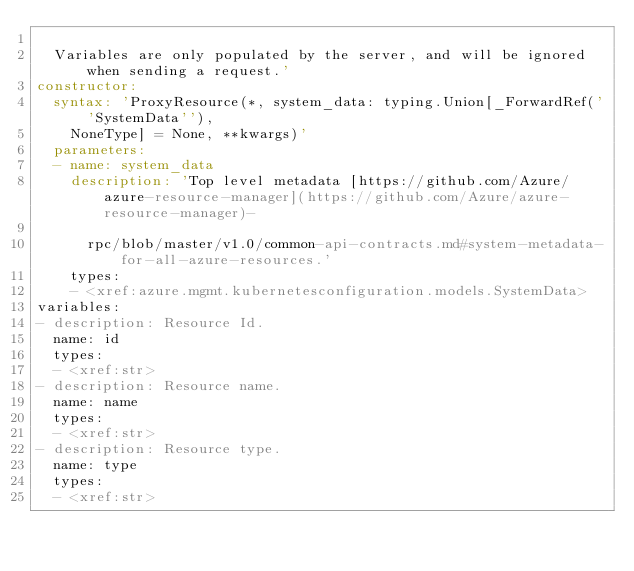<code> <loc_0><loc_0><loc_500><loc_500><_YAML_>
  Variables are only populated by the server, and will be ignored when sending a request.'
constructor:
  syntax: 'ProxyResource(*, system_data: typing.Union[_ForwardRef(''SystemData''),
    NoneType] = None, **kwargs)'
  parameters:
  - name: system_data
    description: 'Top level metadata [https://github.com/Azure/azure-resource-manager](https://github.com/Azure/azure-resource-manager)-

      rpc/blob/master/v1.0/common-api-contracts.md#system-metadata-for-all-azure-resources.'
    types:
    - <xref:azure.mgmt.kubernetesconfiguration.models.SystemData>
variables:
- description: Resource Id.
  name: id
  types:
  - <xref:str>
- description: Resource name.
  name: name
  types:
  - <xref:str>
- description: Resource type.
  name: type
  types:
  - <xref:str>
</code> 